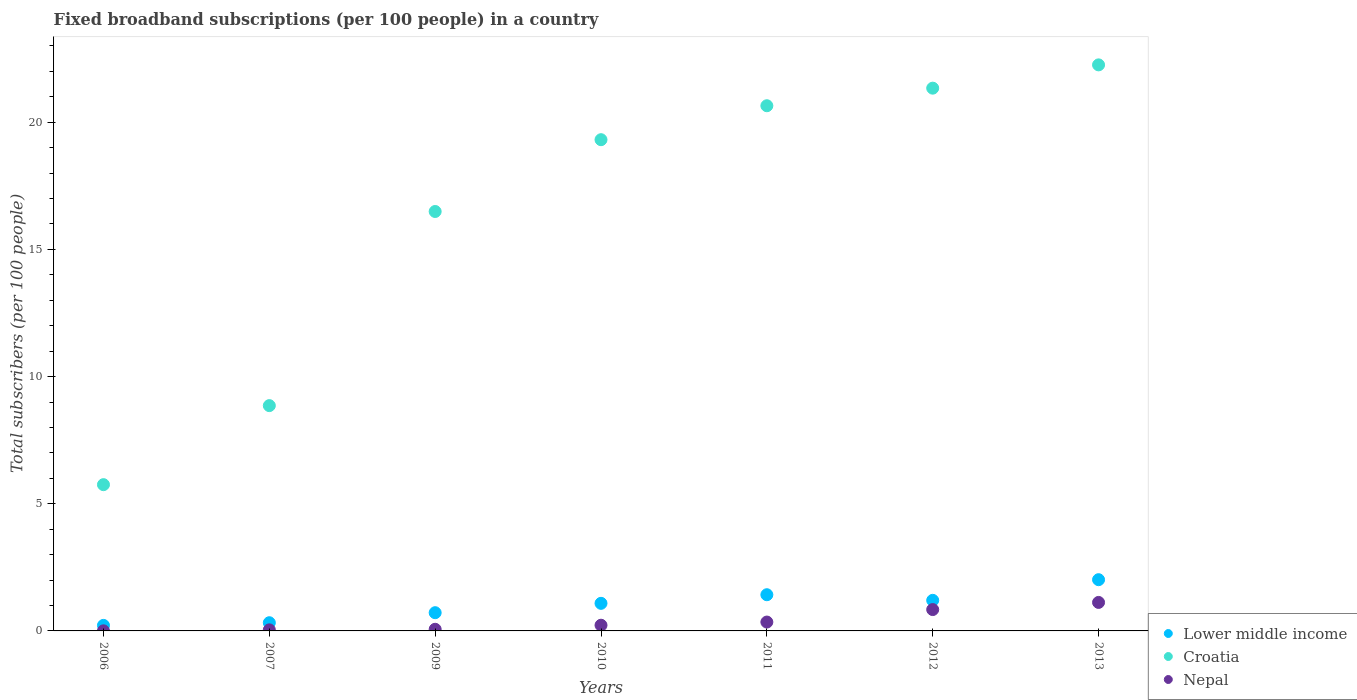How many different coloured dotlines are there?
Keep it short and to the point. 3. Is the number of dotlines equal to the number of legend labels?
Provide a succinct answer. Yes. What is the number of broadband subscriptions in Croatia in 2011?
Keep it short and to the point. 20.65. Across all years, what is the maximum number of broadband subscriptions in Croatia?
Your answer should be very brief. 22.26. Across all years, what is the minimum number of broadband subscriptions in Lower middle income?
Offer a terse response. 0.22. In which year was the number of broadband subscriptions in Nepal minimum?
Offer a very short reply. 2006. What is the total number of broadband subscriptions in Lower middle income in the graph?
Give a very brief answer. 6.98. What is the difference between the number of broadband subscriptions in Lower middle income in 2010 and that in 2013?
Your answer should be very brief. -0.93. What is the difference between the number of broadband subscriptions in Croatia in 2006 and the number of broadband subscriptions in Lower middle income in 2007?
Make the answer very short. 5.43. What is the average number of broadband subscriptions in Nepal per year?
Offer a very short reply. 0.38. In the year 2007, what is the difference between the number of broadband subscriptions in Croatia and number of broadband subscriptions in Lower middle income?
Your answer should be very brief. 8.54. In how many years, is the number of broadband subscriptions in Nepal greater than 5?
Make the answer very short. 0. What is the ratio of the number of broadband subscriptions in Croatia in 2010 to that in 2011?
Your response must be concise. 0.94. Is the number of broadband subscriptions in Lower middle income in 2011 less than that in 2013?
Keep it short and to the point. Yes. What is the difference between the highest and the second highest number of broadband subscriptions in Nepal?
Provide a succinct answer. 0.28. What is the difference between the highest and the lowest number of broadband subscriptions in Nepal?
Provide a succinct answer. 1.12. Does the number of broadband subscriptions in Nepal monotonically increase over the years?
Make the answer very short. Yes. How many years are there in the graph?
Provide a short and direct response. 7. Are the values on the major ticks of Y-axis written in scientific E-notation?
Provide a succinct answer. No. Does the graph contain any zero values?
Offer a very short reply. No. Where does the legend appear in the graph?
Offer a very short reply. Bottom right. How many legend labels are there?
Offer a very short reply. 3. What is the title of the graph?
Your answer should be very brief. Fixed broadband subscriptions (per 100 people) in a country. Does "Djibouti" appear as one of the legend labels in the graph?
Provide a succinct answer. No. What is the label or title of the Y-axis?
Your response must be concise. Total subscribers (per 100 people). What is the Total subscribers (per 100 people) of Lower middle income in 2006?
Make the answer very short. 0.22. What is the Total subscribers (per 100 people) in Croatia in 2006?
Your response must be concise. 5.75. What is the Total subscribers (per 100 people) in Nepal in 2006?
Offer a very short reply. 0. What is the Total subscribers (per 100 people) in Lower middle income in 2007?
Provide a short and direct response. 0.32. What is the Total subscribers (per 100 people) in Croatia in 2007?
Offer a terse response. 8.86. What is the Total subscribers (per 100 people) in Nepal in 2007?
Keep it short and to the point. 0.04. What is the Total subscribers (per 100 people) in Lower middle income in 2009?
Your response must be concise. 0.72. What is the Total subscribers (per 100 people) of Croatia in 2009?
Provide a succinct answer. 16.49. What is the Total subscribers (per 100 people) of Nepal in 2009?
Ensure brevity in your answer.  0.06. What is the Total subscribers (per 100 people) in Lower middle income in 2010?
Offer a very short reply. 1.08. What is the Total subscribers (per 100 people) of Croatia in 2010?
Keep it short and to the point. 19.31. What is the Total subscribers (per 100 people) of Nepal in 2010?
Your answer should be very brief. 0.22. What is the Total subscribers (per 100 people) of Lower middle income in 2011?
Your answer should be compact. 1.42. What is the Total subscribers (per 100 people) in Croatia in 2011?
Offer a very short reply. 20.65. What is the Total subscribers (per 100 people) in Nepal in 2011?
Give a very brief answer. 0.35. What is the Total subscribers (per 100 people) of Lower middle income in 2012?
Provide a short and direct response. 1.2. What is the Total subscribers (per 100 people) of Croatia in 2012?
Provide a short and direct response. 21.34. What is the Total subscribers (per 100 people) of Nepal in 2012?
Your answer should be very brief. 0.84. What is the Total subscribers (per 100 people) of Lower middle income in 2013?
Your response must be concise. 2.01. What is the Total subscribers (per 100 people) of Croatia in 2013?
Provide a succinct answer. 22.26. What is the Total subscribers (per 100 people) of Nepal in 2013?
Your answer should be compact. 1.12. Across all years, what is the maximum Total subscribers (per 100 people) in Lower middle income?
Ensure brevity in your answer.  2.01. Across all years, what is the maximum Total subscribers (per 100 people) of Croatia?
Give a very brief answer. 22.26. Across all years, what is the maximum Total subscribers (per 100 people) of Nepal?
Your response must be concise. 1.12. Across all years, what is the minimum Total subscribers (per 100 people) of Lower middle income?
Offer a terse response. 0.22. Across all years, what is the minimum Total subscribers (per 100 people) in Croatia?
Your answer should be very brief. 5.75. Across all years, what is the minimum Total subscribers (per 100 people) in Nepal?
Offer a terse response. 0. What is the total Total subscribers (per 100 people) in Lower middle income in the graph?
Keep it short and to the point. 6.98. What is the total Total subscribers (per 100 people) in Croatia in the graph?
Ensure brevity in your answer.  114.66. What is the total Total subscribers (per 100 people) of Nepal in the graph?
Make the answer very short. 2.64. What is the difference between the Total subscribers (per 100 people) of Lower middle income in 2006 and that in 2007?
Give a very brief answer. -0.1. What is the difference between the Total subscribers (per 100 people) in Croatia in 2006 and that in 2007?
Provide a succinct answer. -3.11. What is the difference between the Total subscribers (per 100 people) in Nepal in 2006 and that in 2007?
Your answer should be compact. -0.04. What is the difference between the Total subscribers (per 100 people) in Lower middle income in 2006 and that in 2009?
Provide a short and direct response. -0.5. What is the difference between the Total subscribers (per 100 people) in Croatia in 2006 and that in 2009?
Your answer should be compact. -10.74. What is the difference between the Total subscribers (per 100 people) in Nepal in 2006 and that in 2009?
Make the answer very short. -0.06. What is the difference between the Total subscribers (per 100 people) of Lower middle income in 2006 and that in 2010?
Offer a very short reply. -0.87. What is the difference between the Total subscribers (per 100 people) of Croatia in 2006 and that in 2010?
Provide a succinct answer. -13.56. What is the difference between the Total subscribers (per 100 people) in Nepal in 2006 and that in 2010?
Your answer should be compact. -0.22. What is the difference between the Total subscribers (per 100 people) in Lower middle income in 2006 and that in 2011?
Offer a very short reply. -1.21. What is the difference between the Total subscribers (per 100 people) of Croatia in 2006 and that in 2011?
Provide a short and direct response. -14.9. What is the difference between the Total subscribers (per 100 people) in Nepal in 2006 and that in 2011?
Provide a succinct answer. -0.34. What is the difference between the Total subscribers (per 100 people) of Lower middle income in 2006 and that in 2012?
Give a very brief answer. -0.98. What is the difference between the Total subscribers (per 100 people) of Croatia in 2006 and that in 2012?
Make the answer very short. -15.59. What is the difference between the Total subscribers (per 100 people) of Nepal in 2006 and that in 2012?
Provide a succinct answer. -0.84. What is the difference between the Total subscribers (per 100 people) of Lower middle income in 2006 and that in 2013?
Offer a terse response. -1.8. What is the difference between the Total subscribers (per 100 people) in Croatia in 2006 and that in 2013?
Ensure brevity in your answer.  -16.51. What is the difference between the Total subscribers (per 100 people) of Nepal in 2006 and that in 2013?
Offer a terse response. -1.12. What is the difference between the Total subscribers (per 100 people) of Lower middle income in 2007 and that in 2009?
Ensure brevity in your answer.  -0.39. What is the difference between the Total subscribers (per 100 people) of Croatia in 2007 and that in 2009?
Ensure brevity in your answer.  -7.63. What is the difference between the Total subscribers (per 100 people) in Nepal in 2007 and that in 2009?
Ensure brevity in your answer.  -0.02. What is the difference between the Total subscribers (per 100 people) of Lower middle income in 2007 and that in 2010?
Offer a very short reply. -0.76. What is the difference between the Total subscribers (per 100 people) in Croatia in 2007 and that in 2010?
Your response must be concise. -10.46. What is the difference between the Total subscribers (per 100 people) of Nepal in 2007 and that in 2010?
Provide a short and direct response. -0.18. What is the difference between the Total subscribers (per 100 people) of Lower middle income in 2007 and that in 2011?
Your answer should be compact. -1.1. What is the difference between the Total subscribers (per 100 people) in Croatia in 2007 and that in 2011?
Give a very brief answer. -11.79. What is the difference between the Total subscribers (per 100 people) in Nepal in 2007 and that in 2011?
Keep it short and to the point. -0.31. What is the difference between the Total subscribers (per 100 people) in Lower middle income in 2007 and that in 2012?
Your answer should be very brief. -0.88. What is the difference between the Total subscribers (per 100 people) in Croatia in 2007 and that in 2012?
Keep it short and to the point. -12.48. What is the difference between the Total subscribers (per 100 people) in Nepal in 2007 and that in 2012?
Ensure brevity in your answer.  -0.8. What is the difference between the Total subscribers (per 100 people) of Lower middle income in 2007 and that in 2013?
Keep it short and to the point. -1.69. What is the difference between the Total subscribers (per 100 people) in Croatia in 2007 and that in 2013?
Offer a terse response. -13.4. What is the difference between the Total subscribers (per 100 people) in Nepal in 2007 and that in 2013?
Provide a short and direct response. -1.08. What is the difference between the Total subscribers (per 100 people) of Lower middle income in 2009 and that in 2010?
Your response must be concise. -0.37. What is the difference between the Total subscribers (per 100 people) in Croatia in 2009 and that in 2010?
Ensure brevity in your answer.  -2.82. What is the difference between the Total subscribers (per 100 people) of Nepal in 2009 and that in 2010?
Offer a terse response. -0.16. What is the difference between the Total subscribers (per 100 people) of Lower middle income in 2009 and that in 2011?
Provide a short and direct response. -0.71. What is the difference between the Total subscribers (per 100 people) in Croatia in 2009 and that in 2011?
Offer a very short reply. -4.16. What is the difference between the Total subscribers (per 100 people) in Nepal in 2009 and that in 2011?
Ensure brevity in your answer.  -0.28. What is the difference between the Total subscribers (per 100 people) of Lower middle income in 2009 and that in 2012?
Make the answer very short. -0.49. What is the difference between the Total subscribers (per 100 people) in Croatia in 2009 and that in 2012?
Your answer should be very brief. -4.85. What is the difference between the Total subscribers (per 100 people) in Nepal in 2009 and that in 2012?
Give a very brief answer. -0.78. What is the difference between the Total subscribers (per 100 people) in Lower middle income in 2009 and that in 2013?
Your answer should be very brief. -1.3. What is the difference between the Total subscribers (per 100 people) in Croatia in 2009 and that in 2013?
Provide a short and direct response. -5.76. What is the difference between the Total subscribers (per 100 people) of Nepal in 2009 and that in 2013?
Offer a terse response. -1.06. What is the difference between the Total subscribers (per 100 people) of Lower middle income in 2010 and that in 2011?
Make the answer very short. -0.34. What is the difference between the Total subscribers (per 100 people) of Croatia in 2010 and that in 2011?
Give a very brief answer. -1.33. What is the difference between the Total subscribers (per 100 people) of Nepal in 2010 and that in 2011?
Give a very brief answer. -0.12. What is the difference between the Total subscribers (per 100 people) in Lower middle income in 2010 and that in 2012?
Your answer should be very brief. -0.12. What is the difference between the Total subscribers (per 100 people) of Croatia in 2010 and that in 2012?
Ensure brevity in your answer.  -2.03. What is the difference between the Total subscribers (per 100 people) of Nepal in 2010 and that in 2012?
Your answer should be compact. -0.62. What is the difference between the Total subscribers (per 100 people) of Lower middle income in 2010 and that in 2013?
Provide a succinct answer. -0.93. What is the difference between the Total subscribers (per 100 people) of Croatia in 2010 and that in 2013?
Ensure brevity in your answer.  -2.94. What is the difference between the Total subscribers (per 100 people) of Nepal in 2010 and that in 2013?
Provide a short and direct response. -0.9. What is the difference between the Total subscribers (per 100 people) in Lower middle income in 2011 and that in 2012?
Provide a short and direct response. 0.22. What is the difference between the Total subscribers (per 100 people) of Croatia in 2011 and that in 2012?
Your answer should be very brief. -0.69. What is the difference between the Total subscribers (per 100 people) in Nepal in 2011 and that in 2012?
Your answer should be very brief. -0.49. What is the difference between the Total subscribers (per 100 people) in Lower middle income in 2011 and that in 2013?
Ensure brevity in your answer.  -0.59. What is the difference between the Total subscribers (per 100 people) in Croatia in 2011 and that in 2013?
Your answer should be compact. -1.61. What is the difference between the Total subscribers (per 100 people) in Nepal in 2011 and that in 2013?
Your response must be concise. -0.77. What is the difference between the Total subscribers (per 100 people) in Lower middle income in 2012 and that in 2013?
Provide a short and direct response. -0.81. What is the difference between the Total subscribers (per 100 people) in Croatia in 2012 and that in 2013?
Offer a terse response. -0.92. What is the difference between the Total subscribers (per 100 people) of Nepal in 2012 and that in 2013?
Give a very brief answer. -0.28. What is the difference between the Total subscribers (per 100 people) of Lower middle income in 2006 and the Total subscribers (per 100 people) of Croatia in 2007?
Provide a short and direct response. -8.64. What is the difference between the Total subscribers (per 100 people) of Lower middle income in 2006 and the Total subscribers (per 100 people) of Nepal in 2007?
Your answer should be very brief. 0.18. What is the difference between the Total subscribers (per 100 people) of Croatia in 2006 and the Total subscribers (per 100 people) of Nepal in 2007?
Give a very brief answer. 5.71. What is the difference between the Total subscribers (per 100 people) of Lower middle income in 2006 and the Total subscribers (per 100 people) of Croatia in 2009?
Make the answer very short. -16.27. What is the difference between the Total subscribers (per 100 people) in Lower middle income in 2006 and the Total subscribers (per 100 people) in Nepal in 2009?
Make the answer very short. 0.15. What is the difference between the Total subscribers (per 100 people) in Croatia in 2006 and the Total subscribers (per 100 people) in Nepal in 2009?
Your answer should be compact. 5.69. What is the difference between the Total subscribers (per 100 people) in Lower middle income in 2006 and the Total subscribers (per 100 people) in Croatia in 2010?
Give a very brief answer. -19.1. What is the difference between the Total subscribers (per 100 people) of Lower middle income in 2006 and the Total subscribers (per 100 people) of Nepal in 2010?
Your answer should be compact. -0.01. What is the difference between the Total subscribers (per 100 people) in Croatia in 2006 and the Total subscribers (per 100 people) in Nepal in 2010?
Your answer should be compact. 5.53. What is the difference between the Total subscribers (per 100 people) in Lower middle income in 2006 and the Total subscribers (per 100 people) in Croatia in 2011?
Your answer should be compact. -20.43. What is the difference between the Total subscribers (per 100 people) in Lower middle income in 2006 and the Total subscribers (per 100 people) in Nepal in 2011?
Make the answer very short. -0.13. What is the difference between the Total subscribers (per 100 people) in Croatia in 2006 and the Total subscribers (per 100 people) in Nepal in 2011?
Offer a terse response. 5.4. What is the difference between the Total subscribers (per 100 people) in Lower middle income in 2006 and the Total subscribers (per 100 people) in Croatia in 2012?
Ensure brevity in your answer.  -21.12. What is the difference between the Total subscribers (per 100 people) of Lower middle income in 2006 and the Total subscribers (per 100 people) of Nepal in 2012?
Provide a succinct answer. -0.62. What is the difference between the Total subscribers (per 100 people) in Croatia in 2006 and the Total subscribers (per 100 people) in Nepal in 2012?
Offer a very short reply. 4.91. What is the difference between the Total subscribers (per 100 people) of Lower middle income in 2006 and the Total subscribers (per 100 people) of Croatia in 2013?
Keep it short and to the point. -22.04. What is the difference between the Total subscribers (per 100 people) in Lower middle income in 2006 and the Total subscribers (per 100 people) in Nepal in 2013?
Keep it short and to the point. -0.9. What is the difference between the Total subscribers (per 100 people) of Croatia in 2006 and the Total subscribers (per 100 people) of Nepal in 2013?
Give a very brief answer. 4.63. What is the difference between the Total subscribers (per 100 people) of Lower middle income in 2007 and the Total subscribers (per 100 people) of Croatia in 2009?
Provide a succinct answer. -16.17. What is the difference between the Total subscribers (per 100 people) of Lower middle income in 2007 and the Total subscribers (per 100 people) of Nepal in 2009?
Keep it short and to the point. 0.26. What is the difference between the Total subscribers (per 100 people) of Croatia in 2007 and the Total subscribers (per 100 people) of Nepal in 2009?
Provide a succinct answer. 8.79. What is the difference between the Total subscribers (per 100 people) of Lower middle income in 2007 and the Total subscribers (per 100 people) of Croatia in 2010?
Make the answer very short. -18.99. What is the difference between the Total subscribers (per 100 people) in Lower middle income in 2007 and the Total subscribers (per 100 people) in Nepal in 2010?
Keep it short and to the point. 0.1. What is the difference between the Total subscribers (per 100 people) in Croatia in 2007 and the Total subscribers (per 100 people) in Nepal in 2010?
Keep it short and to the point. 8.63. What is the difference between the Total subscribers (per 100 people) in Lower middle income in 2007 and the Total subscribers (per 100 people) in Croatia in 2011?
Your response must be concise. -20.33. What is the difference between the Total subscribers (per 100 people) in Lower middle income in 2007 and the Total subscribers (per 100 people) in Nepal in 2011?
Provide a short and direct response. -0.03. What is the difference between the Total subscribers (per 100 people) in Croatia in 2007 and the Total subscribers (per 100 people) in Nepal in 2011?
Offer a very short reply. 8.51. What is the difference between the Total subscribers (per 100 people) of Lower middle income in 2007 and the Total subscribers (per 100 people) of Croatia in 2012?
Provide a succinct answer. -21.02. What is the difference between the Total subscribers (per 100 people) of Lower middle income in 2007 and the Total subscribers (per 100 people) of Nepal in 2012?
Your response must be concise. -0.52. What is the difference between the Total subscribers (per 100 people) of Croatia in 2007 and the Total subscribers (per 100 people) of Nepal in 2012?
Give a very brief answer. 8.02. What is the difference between the Total subscribers (per 100 people) in Lower middle income in 2007 and the Total subscribers (per 100 people) in Croatia in 2013?
Your response must be concise. -21.93. What is the difference between the Total subscribers (per 100 people) of Lower middle income in 2007 and the Total subscribers (per 100 people) of Nepal in 2013?
Give a very brief answer. -0.8. What is the difference between the Total subscribers (per 100 people) of Croatia in 2007 and the Total subscribers (per 100 people) of Nepal in 2013?
Ensure brevity in your answer.  7.74. What is the difference between the Total subscribers (per 100 people) of Lower middle income in 2009 and the Total subscribers (per 100 people) of Croatia in 2010?
Make the answer very short. -18.6. What is the difference between the Total subscribers (per 100 people) in Lower middle income in 2009 and the Total subscribers (per 100 people) in Nepal in 2010?
Provide a short and direct response. 0.49. What is the difference between the Total subscribers (per 100 people) of Croatia in 2009 and the Total subscribers (per 100 people) of Nepal in 2010?
Your response must be concise. 16.27. What is the difference between the Total subscribers (per 100 people) of Lower middle income in 2009 and the Total subscribers (per 100 people) of Croatia in 2011?
Ensure brevity in your answer.  -19.93. What is the difference between the Total subscribers (per 100 people) of Lower middle income in 2009 and the Total subscribers (per 100 people) of Nepal in 2011?
Your answer should be very brief. 0.37. What is the difference between the Total subscribers (per 100 people) in Croatia in 2009 and the Total subscribers (per 100 people) in Nepal in 2011?
Give a very brief answer. 16.14. What is the difference between the Total subscribers (per 100 people) in Lower middle income in 2009 and the Total subscribers (per 100 people) in Croatia in 2012?
Your answer should be very brief. -20.62. What is the difference between the Total subscribers (per 100 people) of Lower middle income in 2009 and the Total subscribers (per 100 people) of Nepal in 2012?
Your response must be concise. -0.12. What is the difference between the Total subscribers (per 100 people) of Croatia in 2009 and the Total subscribers (per 100 people) of Nepal in 2012?
Offer a terse response. 15.65. What is the difference between the Total subscribers (per 100 people) in Lower middle income in 2009 and the Total subscribers (per 100 people) in Croatia in 2013?
Offer a terse response. -21.54. What is the difference between the Total subscribers (per 100 people) in Lower middle income in 2009 and the Total subscribers (per 100 people) in Nepal in 2013?
Give a very brief answer. -0.4. What is the difference between the Total subscribers (per 100 people) in Croatia in 2009 and the Total subscribers (per 100 people) in Nepal in 2013?
Make the answer very short. 15.37. What is the difference between the Total subscribers (per 100 people) in Lower middle income in 2010 and the Total subscribers (per 100 people) in Croatia in 2011?
Ensure brevity in your answer.  -19.56. What is the difference between the Total subscribers (per 100 people) in Lower middle income in 2010 and the Total subscribers (per 100 people) in Nepal in 2011?
Ensure brevity in your answer.  0.74. What is the difference between the Total subscribers (per 100 people) of Croatia in 2010 and the Total subscribers (per 100 people) of Nepal in 2011?
Make the answer very short. 18.97. What is the difference between the Total subscribers (per 100 people) in Lower middle income in 2010 and the Total subscribers (per 100 people) in Croatia in 2012?
Provide a succinct answer. -20.26. What is the difference between the Total subscribers (per 100 people) of Lower middle income in 2010 and the Total subscribers (per 100 people) of Nepal in 2012?
Ensure brevity in your answer.  0.25. What is the difference between the Total subscribers (per 100 people) in Croatia in 2010 and the Total subscribers (per 100 people) in Nepal in 2012?
Provide a succinct answer. 18.48. What is the difference between the Total subscribers (per 100 people) of Lower middle income in 2010 and the Total subscribers (per 100 people) of Croatia in 2013?
Your answer should be very brief. -21.17. What is the difference between the Total subscribers (per 100 people) of Lower middle income in 2010 and the Total subscribers (per 100 people) of Nepal in 2013?
Provide a short and direct response. -0.04. What is the difference between the Total subscribers (per 100 people) in Croatia in 2010 and the Total subscribers (per 100 people) in Nepal in 2013?
Your answer should be very brief. 18.19. What is the difference between the Total subscribers (per 100 people) in Lower middle income in 2011 and the Total subscribers (per 100 people) in Croatia in 2012?
Your response must be concise. -19.92. What is the difference between the Total subscribers (per 100 people) of Lower middle income in 2011 and the Total subscribers (per 100 people) of Nepal in 2012?
Make the answer very short. 0.58. What is the difference between the Total subscribers (per 100 people) in Croatia in 2011 and the Total subscribers (per 100 people) in Nepal in 2012?
Your answer should be very brief. 19.81. What is the difference between the Total subscribers (per 100 people) of Lower middle income in 2011 and the Total subscribers (per 100 people) of Croatia in 2013?
Offer a very short reply. -20.83. What is the difference between the Total subscribers (per 100 people) of Lower middle income in 2011 and the Total subscribers (per 100 people) of Nepal in 2013?
Keep it short and to the point. 0.3. What is the difference between the Total subscribers (per 100 people) in Croatia in 2011 and the Total subscribers (per 100 people) in Nepal in 2013?
Make the answer very short. 19.53. What is the difference between the Total subscribers (per 100 people) in Lower middle income in 2012 and the Total subscribers (per 100 people) in Croatia in 2013?
Your answer should be very brief. -21.05. What is the difference between the Total subscribers (per 100 people) in Lower middle income in 2012 and the Total subscribers (per 100 people) in Nepal in 2013?
Your answer should be compact. 0.08. What is the difference between the Total subscribers (per 100 people) of Croatia in 2012 and the Total subscribers (per 100 people) of Nepal in 2013?
Offer a terse response. 20.22. What is the average Total subscribers (per 100 people) of Croatia per year?
Provide a succinct answer. 16.38. What is the average Total subscribers (per 100 people) of Nepal per year?
Give a very brief answer. 0.38. In the year 2006, what is the difference between the Total subscribers (per 100 people) of Lower middle income and Total subscribers (per 100 people) of Croatia?
Ensure brevity in your answer.  -5.53. In the year 2006, what is the difference between the Total subscribers (per 100 people) in Lower middle income and Total subscribers (per 100 people) in Nepal?
Ensure brevity in your answer.  0.21. In the year 2006, what is the difference between the Total subscribers (per 100 people) of Croatia and Total subscribers (per 100 people) of Nepal?
Keep it short and to the point. 5.75. In the year 2007, what is the difference between the Total subscribers (per 100 people) of Lower middle income and Total subscribers (per 100 people) of Croatia?
Offer a terse response. -8.54. In the year 2007, what is the difference between the Total subscribers (per 100 people) in Lower middle income and Total subscribers (per 100 people) in Nepal?
Your answer should be compact. 0.28. In the year 2007, what is the difference between the Total subscribers (per 100 people) in Croatia and Total subscribers (per 100 people) in Nepal?
Offer a terse response. 8.82. In the year 2009, what is the difference between the Total subscribers (per 100 people) of Lower middle income and Total subscribers (per 100 people) of Croatia?
Keep it short and to the point. -15.77. In the year 2009, what is the difference between the Total subscribers (per 100 people) in Lower middle income and Total subscribers (per 100 people) in Nepal?
Provide a succinct answer. 0.65. In the year 2009, what is the difference between the Total subscribers (per 100 people) in Croatia and Total subscribers (per 100 people) in Nepal?
Your answer should be very brief. 16.43. In the year 2010, what is the difference between the Total subscribers (per 100 people) in Lower middle income and Total subscribers (per 100 people) in Croatia?
Your answer should be compact. -18.23. In the year 2010, what is the difference between the Total subscribers (per 100 people) of Lower middle income and Total subscribers (per 100 people) of Nepal?
Your response must be concise. 0.86. In the year 2010, what is the difference between the Total subscribers (per 100 people) in Croatia and Total subscribers (per 100 people) in Nepal?
Offer a very short reply. 19.09. In the year 2011, what is the difference between the Total subscribers (per 100 people) in Lower middle income and Total subscribers (per 100 people) in Croatia?
Your answer should be very brief. -19.23. In the year 2011, what is the difference between the Total subscribers (per 100 people) in Lower middle income and Total subscribers (per 100 people) in Nepal?
Give a very brief answer. 1.07. In the year 2011, what is the difference between the Total subscribers (per 100 people) in Croatia and Total subscribers (per 100 people) in Nepal?
Your response must be concise. 20.3. In the year 2012, what is the difference between the Total subscribers (per 100 people) of Lower middle income and Total subscribers (per 100 people) of Croatia?
Make the answer very short. -20.14. In the year 2012, what is the difference between the Total subscribers (per 100 people) of Lower middle income and Total subscribers (per 100 people) of Nepal?
Provide a short and direct response. 0.36. In the year 2012, what is the difference between the Total subscribers (per 100 people) in Croatia and Total subscribers (per 100 people) in Nepal?
Your answer should be very brief. 20.5. In the year 2013, what is the difference between the Total subscribers (per 100 people) in Lower middle income and Total subscribers (per 100 people) in Croatia?
Make the answer very short. -20.24. In the year 2013, what is the difference between the Total subscribers (per 100 people) of Lower middle income and Total subscribers (per 100 people) of Nepal?
Keep it short and to the point. 0.89. In the year 2013, what is the difference between the Total subscribers (per 100 people) in Croatia and Total subscribers (per 100 people) in Nepal?
Your answer should be very brief. 21.14. What is the ratio of the Total subscribers (per 100 people) of Lower middle income in 2006 to that in 2007?
Your answer should be compact. 0.68. What is the ratio of the Total subscribers (per 100 people) of Croatia in 2006 to that in 2007?
Your response must be concise. 0.65. What is the ratio of the Total subscribers (per 100 people) of Nepal in 2006 to that in 2007?
Your answer should be very brief. 0.09. What is the ratio of the Total subscribers (per 100 people) of Lower middle income in 2006 to that in 2009?
Your answer should be very brief. 0.3. What is the ratio of the Total subscribers (per 100 people) of Croatia in 2006 to that in 2009?
Your answer should be compact. 0.35. What is the ratio of the Total subscribers (per 100 people) of Nepal in 2006 to that in 2009?
Keep it short and to the point. 0.06. What is the ratio of the Total subscribers (per 100 people) in Lower middle income in 2006 to that in 2010?
Make the answer very short. 0.2. What is the ratio of the Total subscribers (per 100 people) of Croatia in 2006 to that in 2010?
Offer a very short reply. 0.3. What is the ratio of the Total subscribers (per 100 people) in Nepal in 2006 to that in 2010?
Provide a succinct answer. 0.02. What is the ratio of the Total subscribers (per 100 people) in Lower middle income in 2006 to that in 2011?
Your answer should be compact. 0.15. What is the ratio of the Total subscribers (per 100 people) of Croatia in 2006 to that in 2011?
Make the answer very short. 0.28. What is the ratio of the Total subscribers (per 100 people) of Nepal in 2006 to that in 2011?
Give a very brief answer. 0.01. What is the ratio of the Total subscribers (per 100 people) of Lower middle income in 2006 to that in 2012?
Keep it short and to the point. 0.18. What is the ratio of the Total subscribers (per 100 people) in Croatia in 2006 to that in 2012?
Make the answer very short. 0.27. What is the ratio of the Total subscribers (per 100 people) of Nepal in 2006 to that in 2012?
Make the answer very short. 0. What is the ratio of the Total subscribers (per 100 people) in Lower middle income in 2006 to that in 2013?
Offer a terse response. 0.11. What is the ratio of the Total subscribers (per 100 people) of Croatia in 2006 to that in 2013?
Offer a terse response. 0.26. What is the ratio of the Total subscribers (per 100 people) in Nepal in 2006 to that in 2013?
Make the answer very short. 0. What is the ratio of the Total subscribers (per 100 people) in Lower middle income in 2007 to that in 2009?
Provide a short and direct response. 0.45. What is the ratio of the Total subscribers (per 100 people) of Croatia in 2007 to that in 2009?
Your answer should be very brief. 0.54. What is the ratio of the Total subscribers (per 100 people) in Nepal in 2007 to that in 2009?
Your response must be concise. 0.66. What is the ratio of the Total subscribers (per 100 people) of Lower middle income in 2007 to that in 2010?
Offer a terse response. 0.3. What is the ratio of the Total subscribers (per 100 people) in Croatia in 2007 to that in 2010?
Your response must be concise. 0.46. What is the ratio of the Total subscribers (per 100 people) of Nepal in 2007 to that in 2010?
Provide a short and direct response. 0.19. What is the ratio of the Total subscribers (per 100 people) in Lower middle income in 2007 to that in 2011?
Make the answer very short. 0.23. What is the ratio of the Total subscribers (per 100 people) in Croatia in 2007 to that in 2011?
Keep it short and to the point. 0.43. What is the ratio of the Total subscribers (per 100 people) in Nepal in 2007 to that in 2011?
Provide a short and direct response. 0.12. What is the ratio of the Total subscribers (per 100 people) in Lower middle income in 2007 to that in 2012?
Provide a succinct answer. 0.27. What is the ratio of the Total subscribers (per 100 people) in Croatia in 2007 to that in 2012?
Give a very brief answer. 0.42. What is the ratio of the Total subscribers (per 100 people) of Nepal in 2007 to that in 2012?
Your answer should be very brief. 0.05. What is the ratio of the Total subscribers (per 100 people) in Lower middle income in 2007 to that in 2013?
Keep it short and to the point. 0.16. What is the ratio of the Total subscribers (per 100 people) of Croatia in 2007 to that in 2013?
Ensure brevity in your answer.  0.4. What is the ratio of the Total subscribers (per 100 people) in Nepal in 2007 to that in 2013?
Offer a terse response. 0.04. What is the ratio of the Total subscribers (per 100 people) of Lower middle income in 2009 to that in 2010?
Your answer should be compact. 0.66. What is the ratio of the Total subscribers (per 100 people) of Croatia in 2009 to that in 2010?
Provide a succinct answer. 0.85. What is the ratio of the Total subscribers (per 100 people) in Nepal in 2009 to that in 2010?
Keep it short and to the point. 0.29. What is the ratio of the Total subscribers (per 100 people) in Lower middle income in 2009 to that in 2011?
Provide a short and direct response. 0.5. What is the ratio of the Total subscribers (per 100 people) of Croatia in 2009 to that in 2011?
Provide a succinct answer. 0.8. What is the ratio of the Total subscribers (per 100 people) of Nepal in 2009 to that in 2011?
Give a very brief answer. 0.18. What is the ratio of the Total subscribers (per 100 people) of Lower middle income in 2009 to that in 2012?
Provide a short and direct response. 0.6. What is the ratio of the Total subscribers (per 100 people) in Croatia in 2009 to that in 2012?
Give a very brief answer. 0.77. What is the ratio of the Total subscribers (per 100 people) in Nepal in 2009 to that in 2012?
Ensure brevity in your answer.  0.08. What is the ratio of the Total subscribers (per 100 people) of Lower middle income in 2009 to that in 2013?
Make the answer very short. 0.36. What is the ratio of the Total subscribers (per 100 people) in Croatia in 2009 to that in 2013?
Keep it short and to the point. 0.74. What is the ratio of the Total subscribers (per 100 people) of Nepal in 2009 to that in 2013?
Provide a short and direct response. 0.06. What is the ratio of the Total subscribers (per 100 people) of Lower middle income in 2010 to that in 2011?
Give a very brief answer. 0.76. What is the ratio of the Total subscribers (per 100 people) of Croatia in 2010 to that in 2011?
Provide a short and direct response. 0.94. What is the ratio of the Total subscribers (per 100 people) in Nepal in 2010 to that in 2011?
Provide a succinct answer. 0.64. What is the ratio of the Total subscribers (per 100 people) of Lower middle income in 2010 to that in 2012?
Offer a terse response. 0.9. What is the ratio of the Total subscribers (per 100 people) of Croatia in 2010 to that in 2012?
Your answer should be compact. 0.91. What is the ratio of the Total subscribers (per 100 people) in Nepal in 2010 to that in 2012?
Your answer should be compact. 0.27. What is the ratio of the Total subscribers (per 100 people) in Lower middle income in 2010 to that in 2013?
Your answer should be very brief. 0.54. What is the ratio of the Total subscribers (per 100 people) in Croatia in 2010 to that in 2013?
Offer a terse response. 0.87. What is the ratio of the Total subscribers (per 100 people) of Nepal in 2010 to that in 2013?
Provide a succinct answer. 0.2. What is the ratio of the Total subscribers (per 100 people) in Lower middle income in 2011 to that in 2012?
Your answer should be very brief. 1.18. What is the ratio of the Total subscribers (per 100 people) of Croatia in 2011 to that in 2012?
Offer a terse response. 0.97. What is the ratio of the Total subscribers (per 100 people) of Nepal in 2011 to that in 2012?
Make the answer very short. 0.42. What is the ratio of the Total subscribers (per 100 people) in Lower middle income in 2011 to that in 2013?
Make the answer very short. 0.71. What is the ratio of the Total subscribers (per 100 people) of Croatia in 2011 to that in 2013?
Give a very brief answer. 0.93. What is the ratio of the Total subscribers (per 100 people) of Nepal in 2011 to that in 2013?
Your response must be concise. 0.31. What is the ratio of the Total subscribers (per 100 people) in Lower middle income in 2012 to that in 2013?
Make the answer very short. 0.6. What is the ratio of the Total subscribers (per 100 people) in Croatia in 2012 to that in 2013?
Ensure brevity in your answer.  0.96. What is the ratio of the Total subscribers (per 100 people) in Nepal in 2012 to that in 2013?
Provide a succinct answer. 0.75. What is the difference between the highest and the second highest Total subscribers (per 100 people) of Lower middle income?
Give a very brief answer. 0.59. What is the difference between the highest and the second highest Total subscribers (per 100 people) in Croatia?
Ensure brevity in your answer.  0.92. What is the difference between the highest and the second highest Total subscribers (per 100 people) in Nepal?
Provide a succinct answer. 0.28. What is the difference between the highest and the lowest Total subscribers (per 100 people) in Lower middle income?
Your answer should be compact. 1.8. What is the difference between the highest and the lowest Total subscribers (per 100 people) of Croatia?
Offer a very short reply. 16.51. What is the difference between the highest and the lowest Total subscribers (per 100 people) of Nepal?
Offer a terse response. 1.12. 